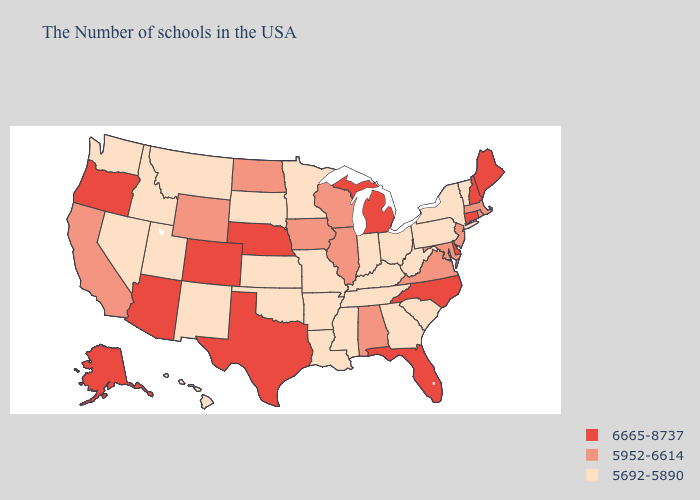Does the first symbol in the legend represent the smallest category?
Quick response, please. No. Does Wyoming have the lowest value in the USA?
Keep it brief. No. Name the states that have a value in the range 5952-6614?
Write a very short answer. Massachusetts, Rhode Island, New Jersey, Maryland, Virginia, Alabama, Wisconsin, Illinois, Iowa, North Dakota, Wyoming, California. Does Rhode Island have a lower value than New York?
Concise answer only. No. What is the lowest value in the MidWest?
Quick response, please. 5692-5890. Does West Virginia have a lower value than Alabama?
Be succinct. Yes. What is the value of Connecticut?
Quick response, please. 6665-8737. Does Florida have the same value as New Hampshire?
Give a very brief answer. Yes. Does Maryland have the same value as Rhode Island?
Be succinct. Yes. Which states have the lowest value in the USA?
Be succinct. Vermont, New York, Pennsylvania, South Carolina, West Virginia, Ohio, Georgia, Kentucky, Indiana, Tennessee, Mississippi, Louisiana, Missouri, Arkansas, Minnesota, Kansas, Oklahoma, South Dakota, New Mexico, Utah, Montana, Idaho, Nevada, Washington, Hawaii. Does the first symbol in the legend represent the smallest category?
Write a very short answer. No. Does South Dakota have a lower value than New Jersey?
Short answer required. Yes. Does Utah have a higher value than Virginia?
Write a very short answer. No. What is the value of Idaho?
Write a very short answer. 5692-5890. Name the states that have a value in the range 5952-6614?
Concise answer only. Massachusetts, Rhode Island, New Jersey, Maryland, Virginia, Alabama, Wisconsin, Illinois, Iowa, North Dakota, Wyoming, California. 